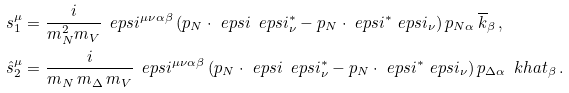Convert formula to latex. <formula><loc_0><loc_0><loc_500><loc_500>s _ { 1 } ^ { \mu } & = \frac { i } { m _ { N } ^ { 2 } m _ { V } } \, \ e p s i ^ { \mu \nu \alpha \beta } \, ( p _ { N } \cdot \ e p s i \, \ e p s i _ { \nu } ^ { * } - p _ { N } \cdot \ e p s i ^ { * } \ e p s i _ { \nu } ) \, p _ { N \alpha } \, \overline { k } _ { \beta } \, , \\ \hat { s } _ { 2 } ^ { \mu } & = \frac { i } { m _ { N } \, m _ { \Delta } \, m _ { V } } \, \ e p s i ^ { \mu \nu \alpha \beta } \, ( p _ { N } \cdot \ e p s i \, \ e p s i _ { \nu } ^ { * } - p _ { N } \cdot \ e p s i ^ { * } \ e p s i _ { \nu } ) \, p _ { \Delta \alpha } \, \ k h a t _ { \beta } \, .</formula> 